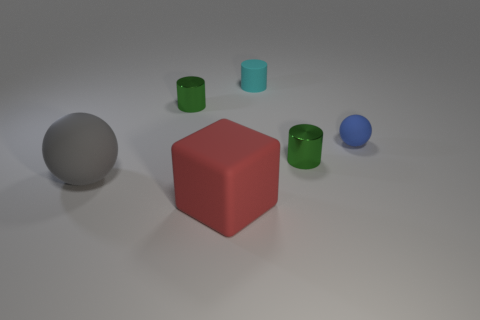Add 3 small blue matte balls. How many objects exist? 9 Subtract all cubes. How many objects are left? 5 Subtract all blocks. Subtract all tiny cyan things. How many objects are left? 4 Add 6 big spheres. How many big spheres are left? 7 Add 2 small cyan metallic cylinders. How many small cyan metallic cylinders exist? 2 Subtract 0 brown cubes. How many objects are left? 6 